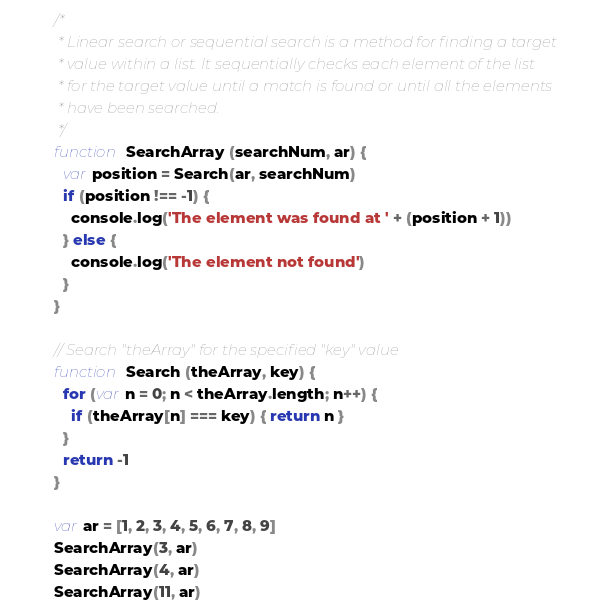<code> <loc_0><loc_0><loc_500><loc_500><_JavaScript_>/*
 * Linear search or sequential search is a method for finding a target
 * value within a list. It sequentially checks each element of the list
 * for the target value until a match is found or until all the elements
 * have been searched.
 */
function SearchArray (searchNum, ar) {
  var position = Search(ar, searchNum)
  if (position !== -1) {
    console.log('The element was found at ' + (position + 1))
  } else {
    console.log('The element not found')
  }
}

// Search "theArray" for the specified "key" value
function Search (theArray, key) {
  for (var n = 0; n < theArray.length; n++) {
    if (theArray[n] === key) { return n }
  }
  return -1
}

var ar = [1, 2, 3, 4, 5, 6, 7, 8, 9]
SearchArray(3, ar)
SearchArray(4, ar)
SearchArray(11, ar)
</code> 